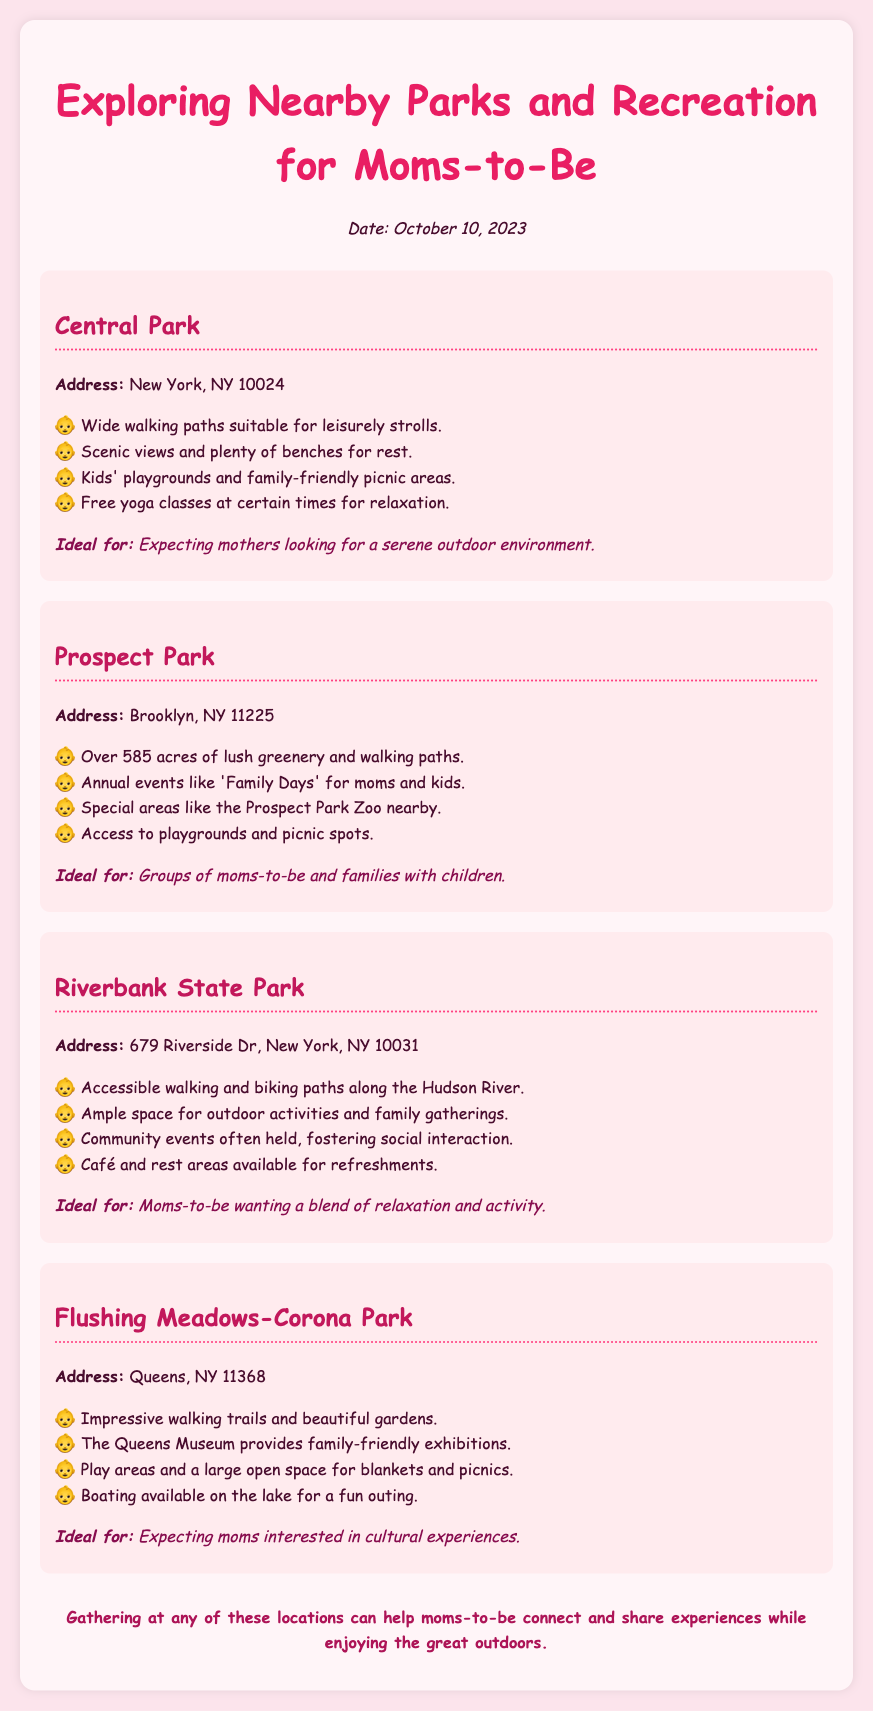What is the address of Central Park? The address of Central Park is mentioned in the document as New York, NY 10024.
Answer: New York, NY 10024 How many acres does Prospect Park cover? The document states that Prospect Park has over 585 acres of greenery and walking paths.
Answer: 585 acres What amenities are available at Riverbank State Park? The document lists several amenities including walking and biking paths, café, and rest areas for refreshments.
Answer: Café and rest areas Which park is ideal for expecting moms interested in cultural experiences? The document specifies that Flushing Meadows-Corona Park is ideal for expecting moms interested in cultural experiences.
Answer: Flushing Meadows-Corona Park What special events does Prospect Park host? The document mentions that Prospect Park hosts annual events like 'Family Days' for moms and kids.
Answer: Family Days How many locations are mentioned in the document? The document lists four parks and recreation areas suitable for moms-to-be.
Answer: Four What type of outdoor activity is available at Riverbank State Park? The document indicates that Riverbank State Park offers outdoor activities along the Hudson River.
Answer: Outdoor activities Which park offers free yoga classes? The document states that Central Park offers free yoga classes at certain times.
Answer: Central Park 